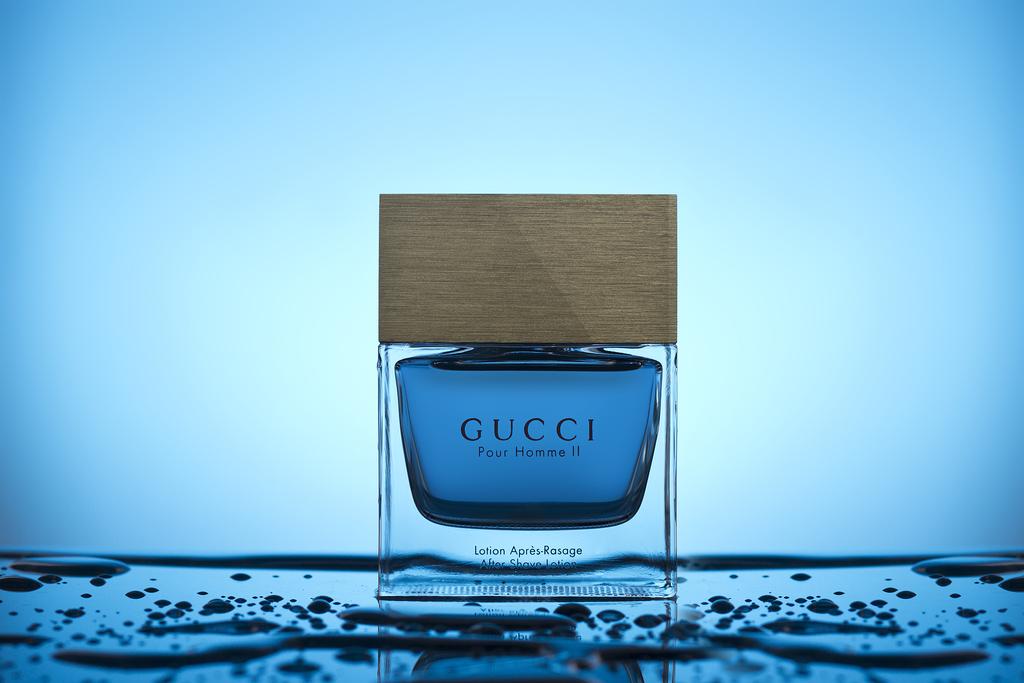What brand of product is shown?
Your answer should be very brief. Gucci. What is the name of the gucci scent in this bottle?
Offer a terse response. Pour homme ii. 